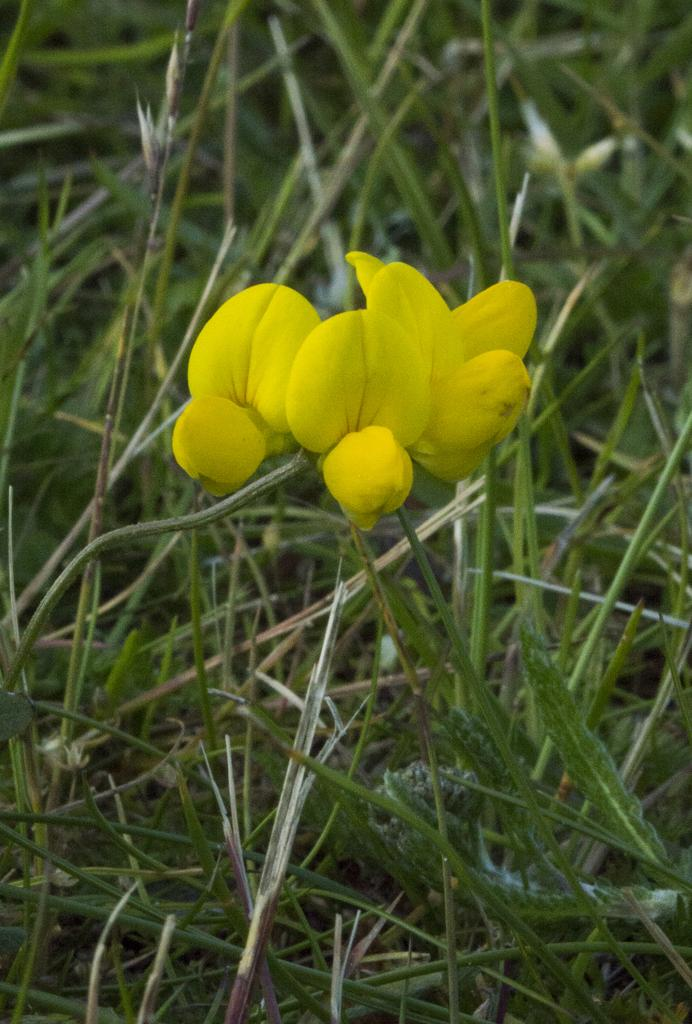What type of plants can be seen in the image? There are flowers in the image. What color are the flowers? The flowers are yellow. Where are the flowers located in the image? The flowers are in the middle of the image. What can be seen in the background of the image? There is grass visible in the background of the image. How is the background of the image depicted? The background of the image is blurred. Can you tell me how many firemen are wearing masks in the image? There are no firemen or masks present in the image; it features yellow flowers in the middle of the frame with a blurred grassy background. 